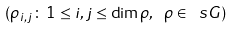<formula> <loc_0><loc_0><loc_500><loc_500>( \rho _ { i , j } \colon \, 1 \leq i , j \leq \dim \rho , \ \rho \in \ s G )</formula> 